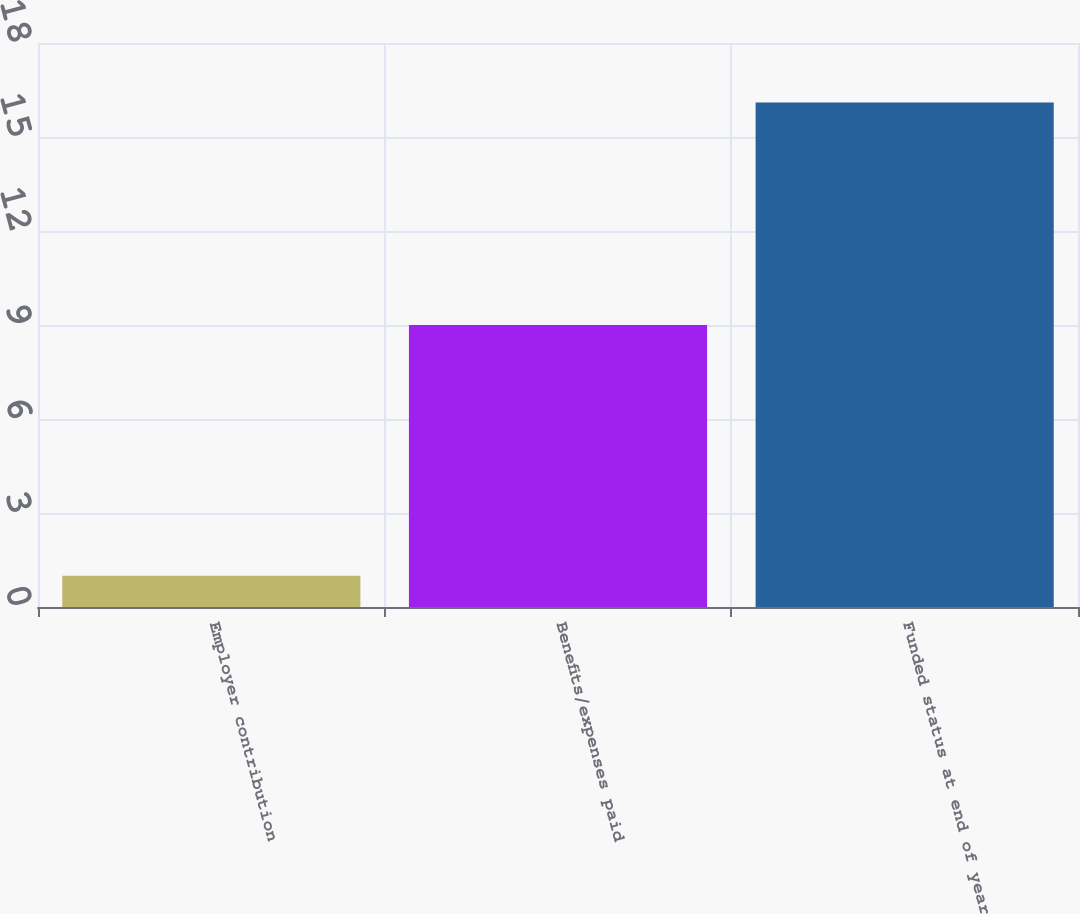Convert chart. <chart><loc_0><loc_0><loc_500><loc_500><bar_chart><fcel>Employer contribution<fcel>Benefits/expenses paid<fcel>Funded status at end of year<nl><fcel>1<fcel>9<fcel>16.1<nl></chart> 